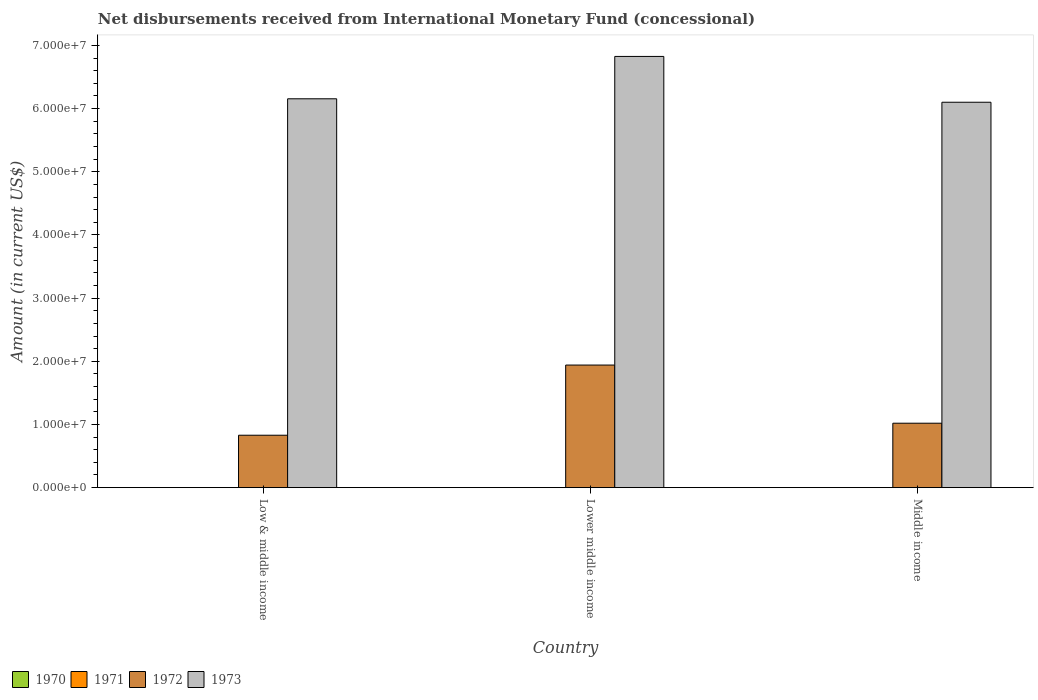How many different coloured bars are there?
Give a very brief answer. 2. How many groups of bars are there?
Your answer should be compact. 3. Are the number of bars per tick equal to the number of legend labels?
Offer a very short reply. No. How many bars are there on the 2nd tick from the left?
Provide a succinct answer. 2. How many bars are there on the 2nd tick from the right?
Keep it short and to the point. 2. What is the label of the 2nd group of bars from the left?
Provide a succinct answer. Lower middle income. In how many cases, is the number of bars for a given country not equal to the number of legend labels?
Ensure brevity in your answer.  3. Across all countries, what is the maximum amount of disbursements received from International Monetary Fund in 1973?
Ensure brevity in your answer.  6.83e+07. Across all countries, what is the minimum amount of disbursements received from International Monetary Fund in 1972?
Ensure brevity in your answer.  8.30e+06. In which country was the amount of disbursements received from International Monetary Fund in 1973 maximum?
Your answer should be very brief. Lower middle income. What is the total amount of disbursements received from International Monetary Fund in 1972 in the graph?
Make the answer very short. 3.79e+07. What is the difference between the amount of disbursements received from International Monetary Fund in 1972 in Lower middle income and that in Middle income?
Make the answer very short. 9.21e+06. What is the difference between the amount of disbursements received from International Monetary Fund in 1970 in Low & middle income and the amount of disbursements received from International Monetary Fund in 1971 in Middle income?
Offer a very short reply. 0. What is the average amount of disbursements received from International Monetary Fund in 1972 per country?
Offer a very short reply. 1.26e+07. What is the difference between the amount of disbursements received from International Monetary Fund of/in 1973 and amount of disbursements received from International Monetary Fund of/in 1972 in Low & middle income?
Ensure brevity in your answer.  5.33e+07. In how many countries, is the amount of disbursements received from International Monetary Fund in 1973 greater than 28000000 US$?
Offer a very short reply. 3. What is the ratio of the amount of disbursements received from International Monetary Fund in 1973 in Low & middle income to that in Middle income?
Provide a short and direct response. 1.01. Is the amount of disbursements received from International Monetary Fund in 1972 in Lower middle income less than that in Middle income?
Provide a succinct answer. No. Is the difference between the amount of disbursements received from International Monetary Fund in 1973 in Lower middle income and Middle income greater than the difference between the amount of disbursements received from International Monetary Fund in 1972 in Lower middle income and Middle income?
Provide a short and direct response. No. What is the difference between the highest and the second highest amount of disbursements received from International Monetary Fund in 1973?
Keep it short and to the point. -7.25e+06. What is the difference between the highest and the lowest amount of disbursements received from International Monetary Fund in 1973?
Your response must be concise. 7.25e+06. Is it the case that in every country, the sum of the amount of disbursements received from International Monetary Fund in 1971 and amount of disbursements received from International Monetary Fund in 1970 is greater than the sum of amount of disbursements received from International Monetary Fund in 1973 and amount of disbursements received from International Monetary Fund in 1972?
Offer a terse response. No. Is it the case that in every country, the sum of the amount of disbursements received from International Monetary Fund in 1973 and amount of disbursements received from International Monetary Fund in 1971 is greater than the amount of disbursements received from International Monetary Fund in 1970?
Make the answer very short. Yes. Are all the bars in the graph horizontal?
Ensure brevity in your answer.  No. Are the values on the major ticks of Y-axis written in scientific E-notation?
Keep it short and to the point. Yes. Does the graph contain any zero values?
Your answer should be compact. Yes. Where does the legend appear in the graph?
Give a very brief answer. Bottom left. How are the legend labels stacked?
Keep it short and to the point. Horizontal. What is the title of the graph?
Offer a terse response. Net disbursements received from International Monetary Fund (concessional). What is the label or title of the Y-axis?
Keep it short and to the point. Amount (in current US$). What is the Amount (in current US$) of 1971 in Low & middle income?
Provide a short and direct response. 0. What is the Amount (in current US$) of 1972 in Low & middle income?
Provide a short and direct response. 8.30e+06. What is the Amount (in current US$) of 1973 in Low & middle income?
Your answer should be very brief. 6.16e+07. What is the Amount (in current US$) of 1971 in Lower middle income?
Ensure brevity in your answer.  0. What is the Amount (in current US$) in 1972 in Lower middle income?
Your answer should be very brief. 1.94e+07. What is the Amount (in current US$) of 1973 in Lower middle income?
Provide a succinct answer. 6.83e+07. What is the Amount (in current US$) in 1970 in Middle income?
Your response must be concise. 0. What is the Amount (in current US$) of 1971 in Middle income?
Your answer should be compact. 0. What is the Amount (in current US$) in 1972 in Middle income?
Make the answer very short. 1.02e+07. What is the Amount (in current US$) of 1973 in Middle income?
Keep it short and to the point. 6.10e+07. Across all countries, what is the maximum Amount (in current US$) in 1972?
Offer a very short reply. 1.94e+07. Across all countries, what is the maximum Amount (in current US$) in 1973?
Your answer should be compact. 6.83e+07. Across all countries, what is the minimum Amount (in current US$) in 1972?
Provide a succinct answer. 8.30e+06. Across all countries, what is the minimum Amount (in current US$) in 1973?
Your answer should be very brief. 6.10e+07. What is the total Amount (in current US$) in 1971 in the graph?
Your answer should be very brief. 0. What is the total Amount (in current US$) of 1972 in the graph?
Give a very brief answer. 3.79e+07. What is the total Amount (in current US$) of 1973 in the graph?
Offer a terse response. 1.91e+08. What is the difference between the Amount (in current US$) in 1972 in Low & middle income and that in Lower middle income?
Make the answer very short. -1.11e+07. What is the difference between the Amount (in current US$) in 1973 in Low & middle income and that in Lower middle income?
Offer a terse response. -6.70e+06. What is the difference between the Amount (in current US$) of 1972 in Low & middle income and that in Middle income?
Your answer should be compact. -1.90e+06. What is the difference between the Amount (in current US$) in 1973 in Low & middle income and that in Middle income?
Provide a succinct answer. 5.46e+05. What is the difference between the Amount (in current US$) of 1972 in Lower middle income and that in Middle income?
Ensure brevity in your answer.  9.21e+06. What is the difference between the Amount (in current US$) of 1973 in Lower middle income and that in Middle income?
Your response must be concise. 7.25e+06. What is the difference between the Amount (in current US$) of 1972 in Low & middle income and the Amount (in current US$) of 1973 in Lower middle income?
Keep it short and to the point. -6.00e+07. What is the difference between the Amount (in current US$) in 1972 in Low & middle income and the Amount (in current US$) in 1973 in Middle income?
Give a very brief answer. -5.27e+07. What is the difference between the Amount (in current US$) in 1972 in Lower middle income and the Amount (in current US$) in 1973 in Middle income?
Ensure brevity in your answer.  -4.16e+07. What is the average Amount (in current US$) of 1972 per country?
Provide a succinct answer. 1.26e+07. What is the average Amount (in current US$) in 1973 per country?
Your response must be concise. 6.36e+07. What is the difference between the Amount (in current US$) of 1972 and Amount (in current US$) of 1973 in Low & middle income?
Keep it short and to the point. -5.33e+07. What is the difference between the Amount (in current US$) in 1972 and Amount (in current US$) in 1973 in Lower middle income?
Your response must be concise. -4.89e+07. What is the difference between the Amount (in current US$) in 1972 and Amount (in current US$) in 1973 in Middle income?
Make the answer very short. -5.08e+07. What is the ratio of the Amount (in current US$) of 1972 in Low & middle income to that in Lower middle income?
Your answer should be compact. 0.43. What is the ratio of the Amount (in current US$) in 1973 in Low & middle income to that in Lower middle income?
Offer a terse response. 0.9. What is the ratio of the Amount (in current US$) of 1972 in Low & middle income to that in Middle income?
Your answer should be compact. 0.81. What is the ratio of the Amount (in current US$) of 1973 in Low & middle income to that in Middle income?
Offer a terse response. 1.01. What is the ratio of the Amount (in current US$) of 1972 in Lower middle income to that in Middle income?
Give a very brief answer. 1.9. What is the ratio of the Amount (in current US$) of 1973 in Lower middle income to that in Middle income?
Offer a very short reply. 1.12. What is the difference between the highest and the second highest Amount (in current US$) of 1972?
Offer a very short reply. 9.21e+06. What is the difference between the highest and the second highest Amount (in current US$) of 1973?
Offer a very short reply. 6.70e+06. What is the difference between the highest and the lowest Amount (in current US$) of 1972?
Give a very brief answer. 1.11e+07. What is the difference between the highest and the lowest Amount (in current US$) in 1973?
Offer a very short reply. 7.25e+06. 